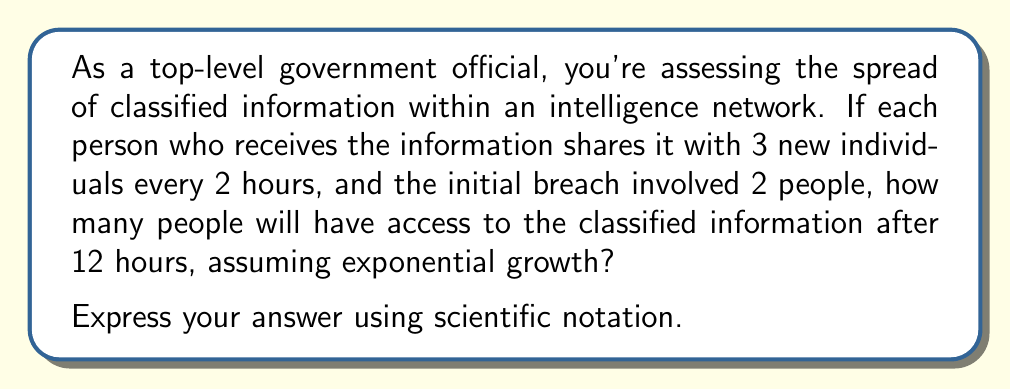Could you help me with this problem? Let's approach this step-by-step:

1) First, we need to determine how many "sharing cycles" occur in 12 hours:
   $\frac{12 \text{ hours}}{2 \text{ hours per cycle}} = 6 \text{ cycles}$

2) We can represent this situation with the exponential growth formula:
   $P = P_0 \cdot b^n$
   Where:
   $P$ is the final number of people
   $P_0$ is the initial number of people (2 in this case)
   $b$ is the growth factor per cycle (3 in this case)
   $n$ is the number of cycles (6 in this case)

3) Let's substitute these values:
   $P = 2 \cdot 3^6$

4) Now we can calculate:
   $P = 2 \cdot 3^6$
   $= 2 \cdot 729$
   $= 1458$

5) To express this in scientific notation, we move the decimal point to be after the first non-zero digit and count the number of places moved:
   $1458 = 1.458 \times 10^3$

Therefore, after 12 hours, 1.458 × 10³ people will have access to the classified information.
Answer: $1.458 \times 10^3$ people 